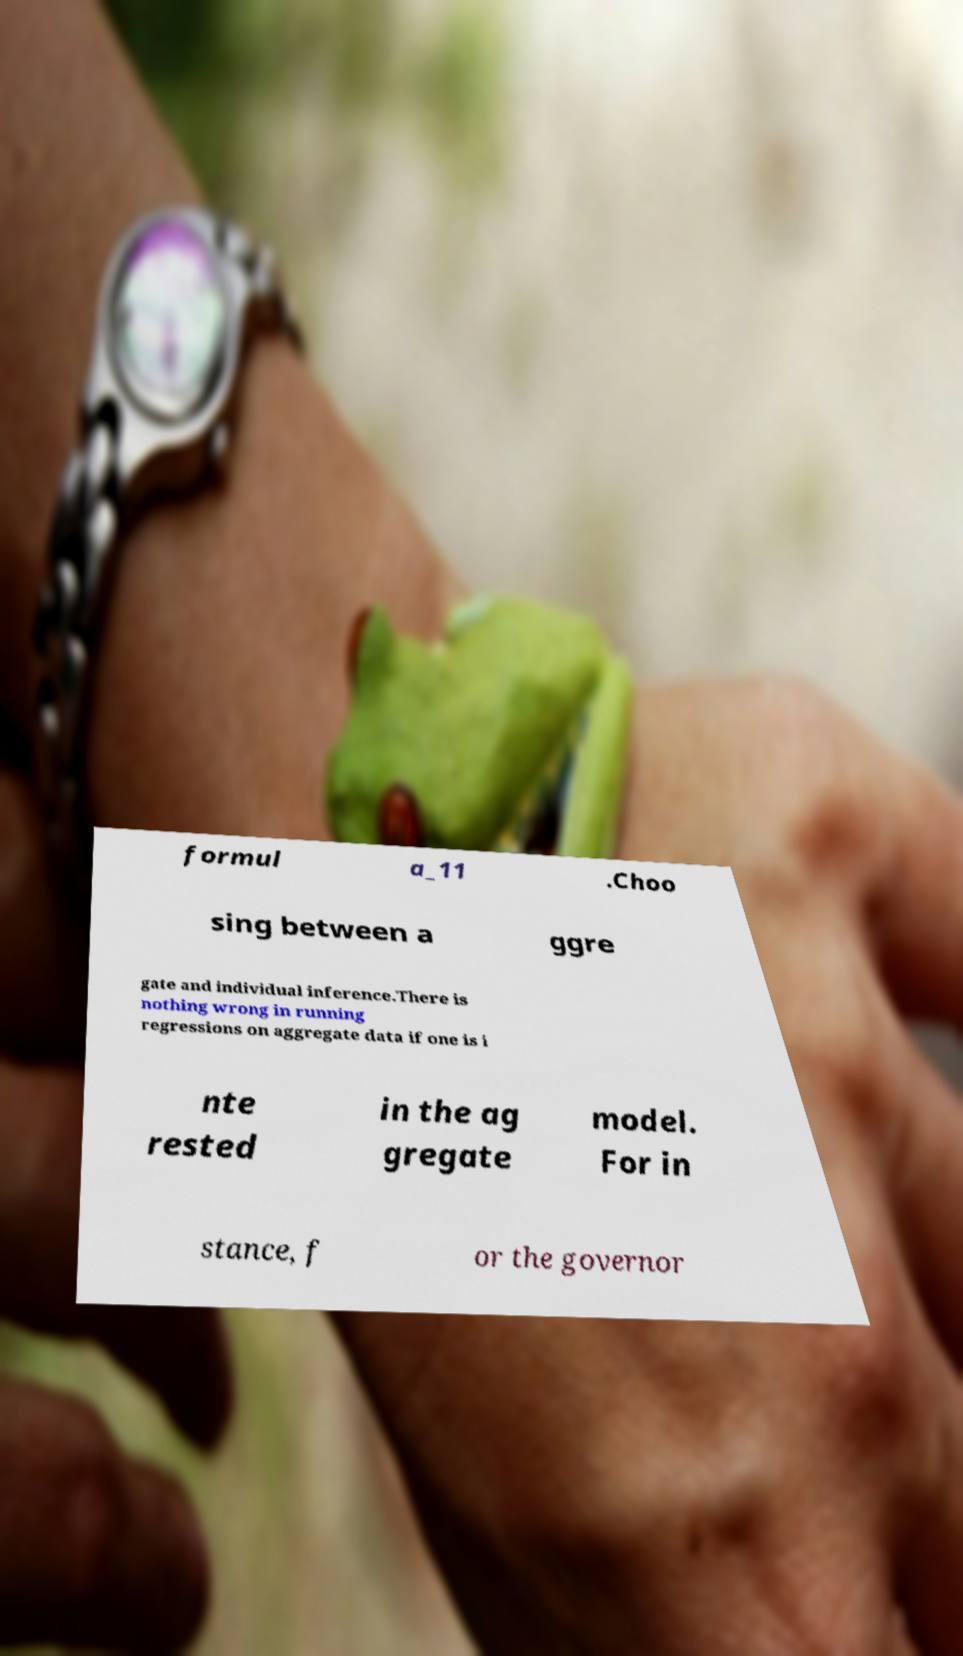Could you extract and type out the text from this image? formul a_11 .Choo sing between a ggre gate and individual inference.There is nothing wrong in running regressions on aggregate data if one is i nte rested in the ag gregate model. For in stance, f or the governor 